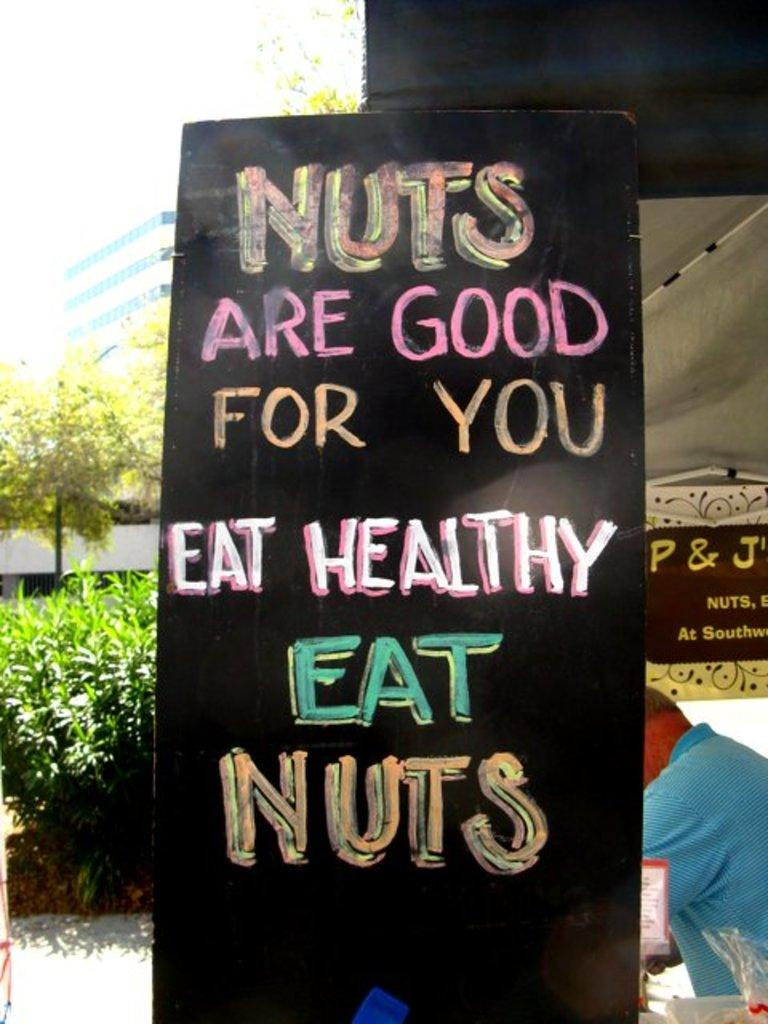What is the main object in the foreground of the image? There is a black color board in the foreground of the image. What is written or displayed on the black color board? There is text on the black color board. Where is the man located in the image? The man is under a tent on the right side of the image. What type of vegetation or plants can be seen on the left side of the image? There is greenery on the left side of the image. What structures are visible on the left side of the image? There are buildings visible on the left side of the image. What color is the grandmother's paint in the image? There is no grandmother or paint present in the image. 